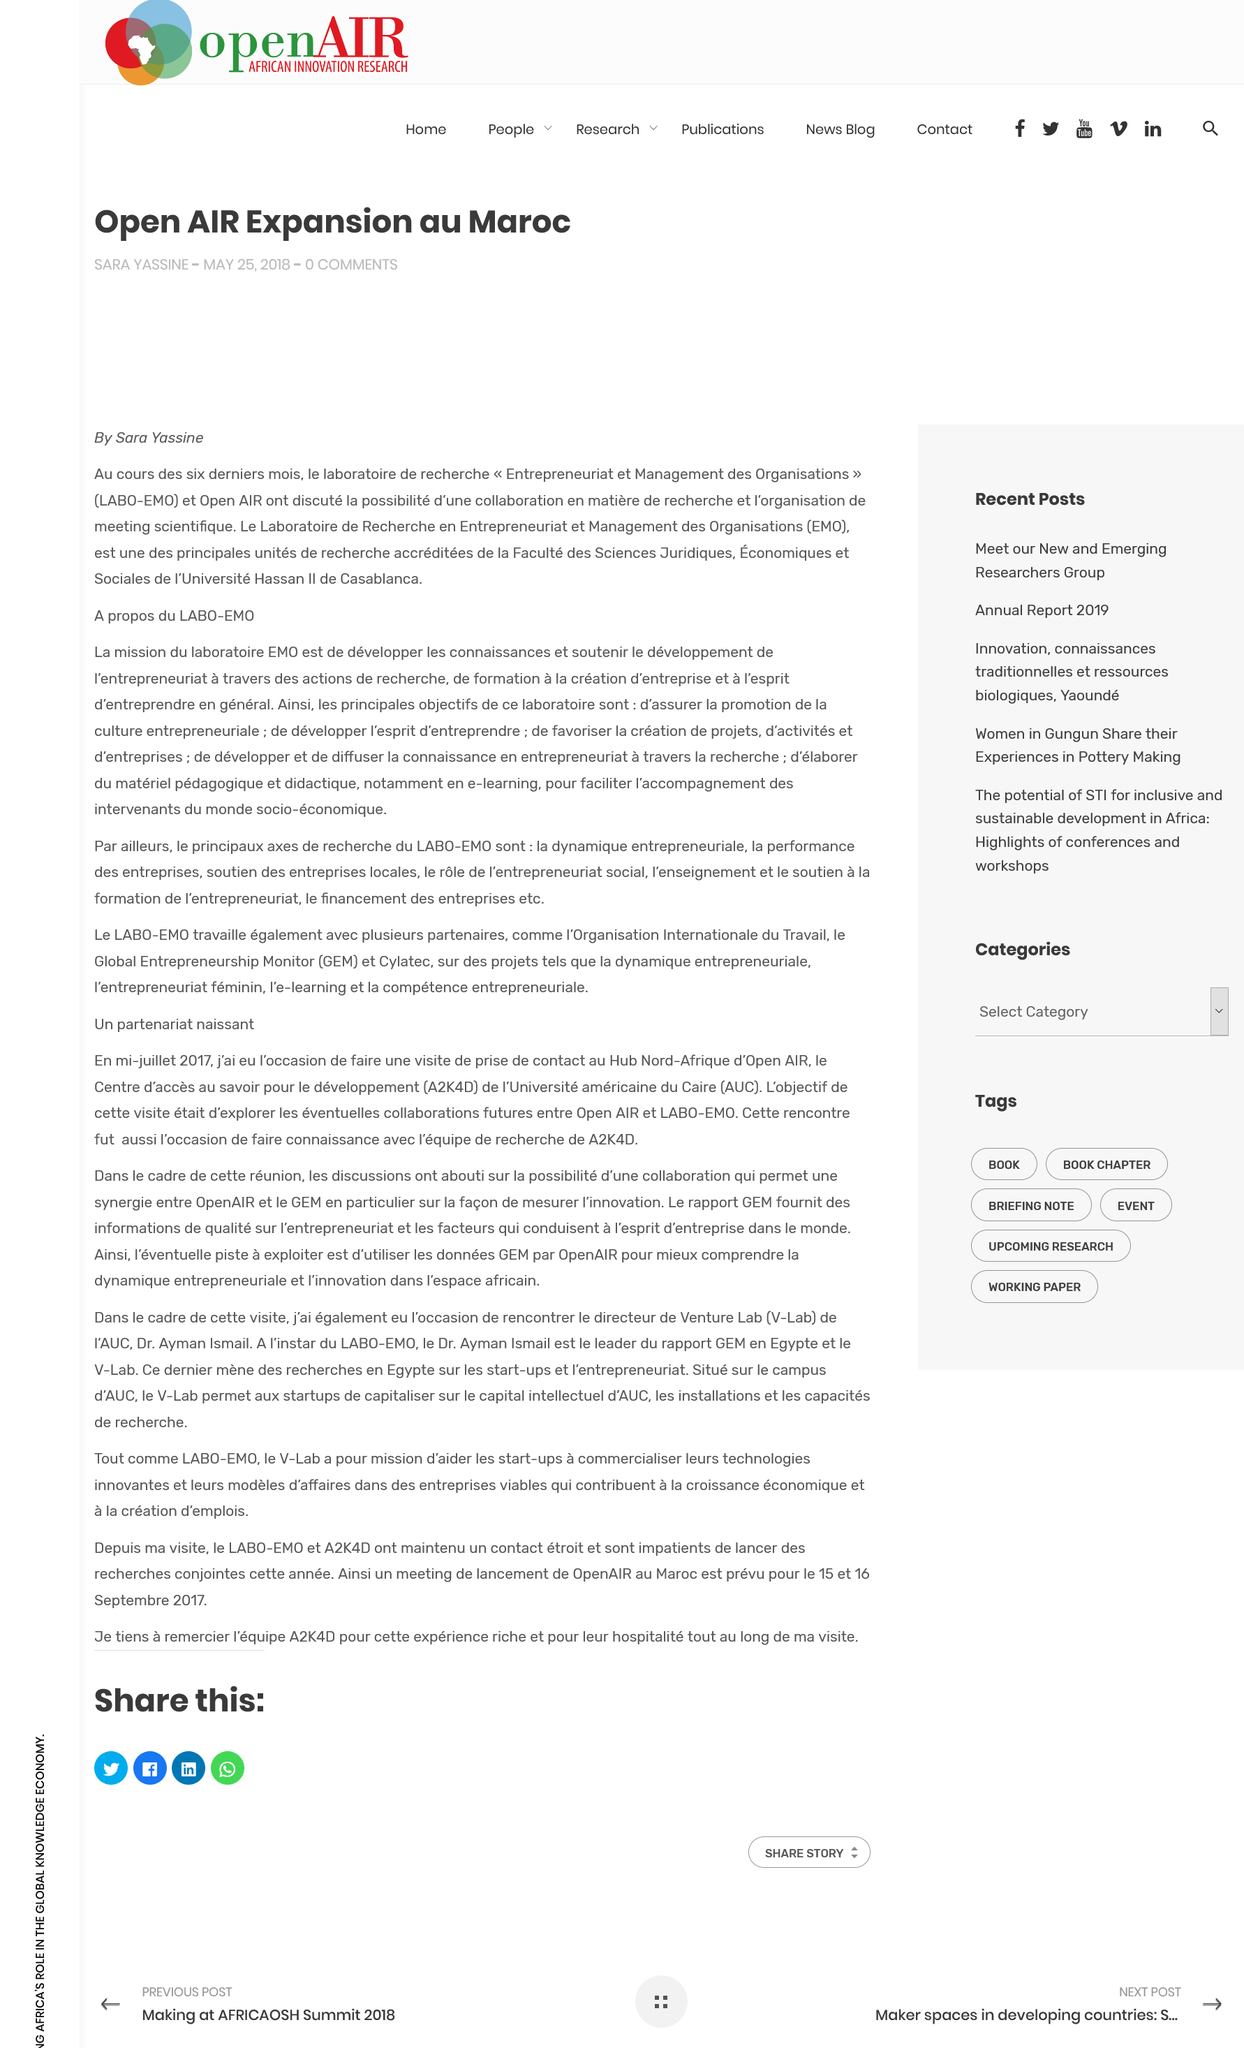Outline some significant characteristics in this image. This article discusses a partnership among various organizations to expand outdoor activities in Morocco. The article was published by Sara Yassine. The article was published on May 25, 2018. 